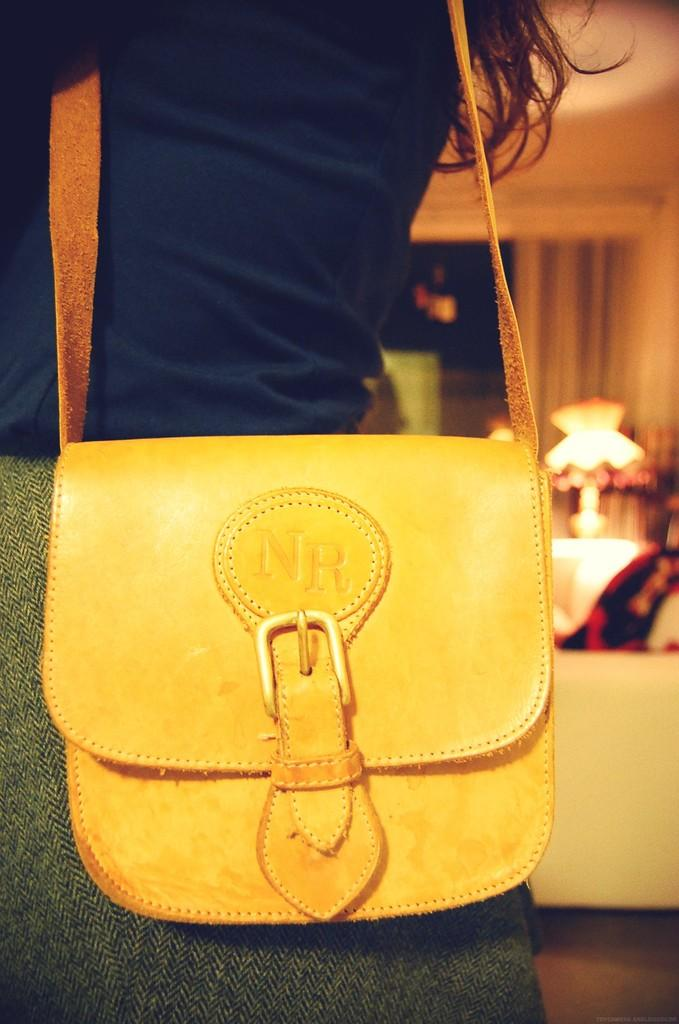Who or what is present in the image? There is a person in the image. What is the person holding or carrying? The person is carrying a bag. What type of spy equipment can be seen in the person's mitten in the image? There is no mitten or spy equipment present in the image. 